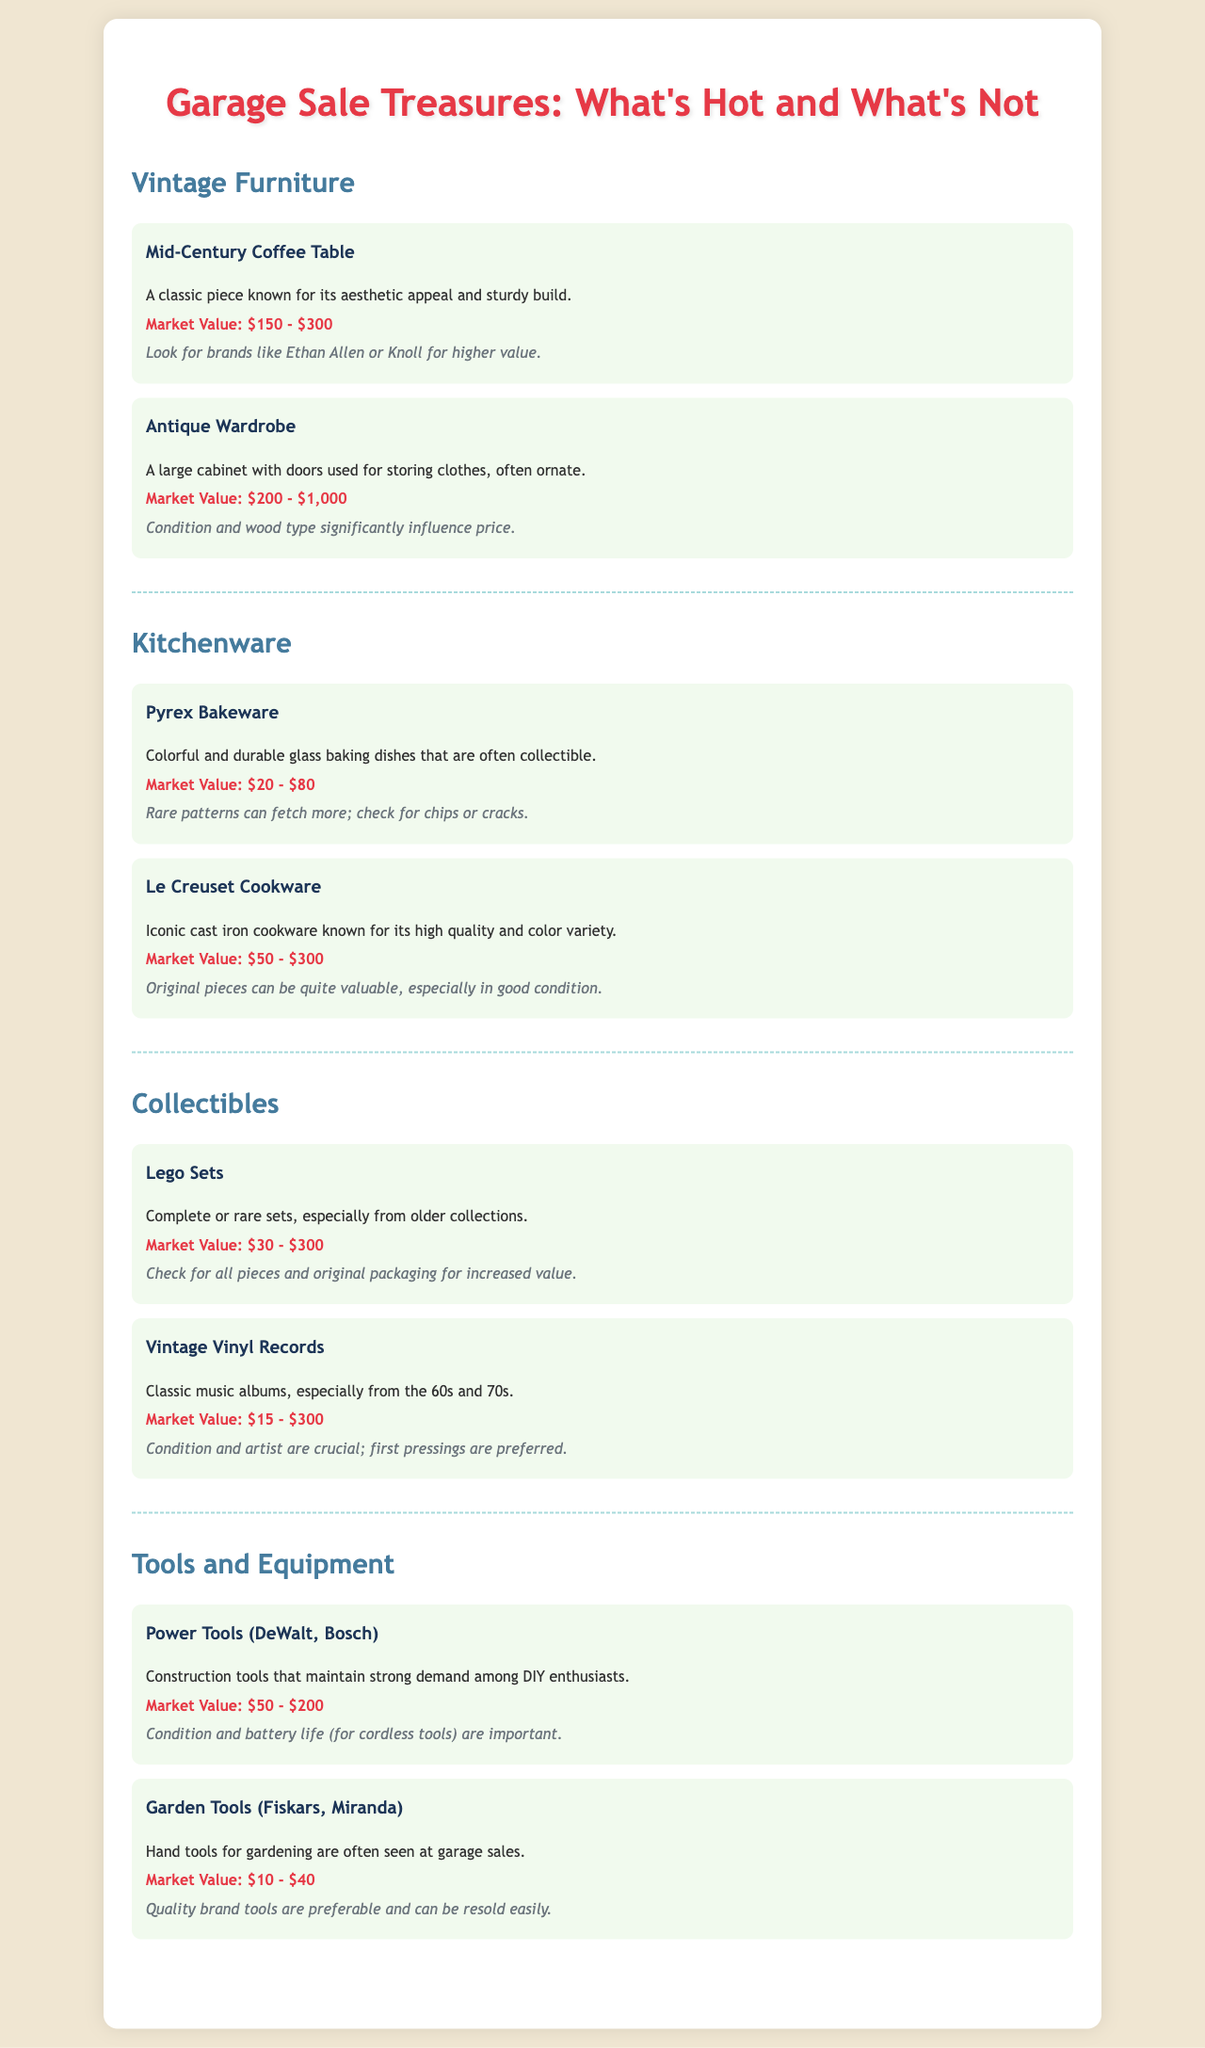What is the market value range for a Mid-Century Coffee Table? The market value range for a Mid-Century Coffee Table is specified within the document as $150 - $300.
Answer: $150 - $300 What type of cookware is known for its high quality and color variety? The document states that Le Creuset Cookware is iconic for its high quality and variety of colors.
Answer: Le Creuset Cookware What influences the market value of an Antique Wardrobe? According to the document, condition and wood type significantly influence the price of an Antique Wardrobe.
Answer: Condition and wood type What is the market value range for Lego Sets? The document indicates that the market value for Lego Sets ranges from $30 - $300.
Answer: $30 - $300 Which brand of garden tools is mentioned as preferable? The document specifically lists Fiskars as a quality brand for garden tools that are often seen at garage sales.
Answer: Fiskars How does the condition of items affect their value at garage sales? The document mentions that condition affects the market value of various items, such as Pyrex Bakeware and Power Tools.
Answer: Condition What is a crucial factor for Vintage Vinyl Records? The document points out that the condition and artist are crucial factors for determining the value of Vintage Vinyl Records.
Answer: Condition and artist Which tools maintain strong demand among DIY enthusiasts? The document identifies Power Tools from brands like DeWalt and Bosch as maintaining strong demand among DIY enthusiasts.
Answer: Power Tools What can increase the value of Pyrex Bakeware? According to the document, rare patterns can fetch more value for Pyrex Bakeware, along with checking for chips or cracks.
Answer: Rare patterns 